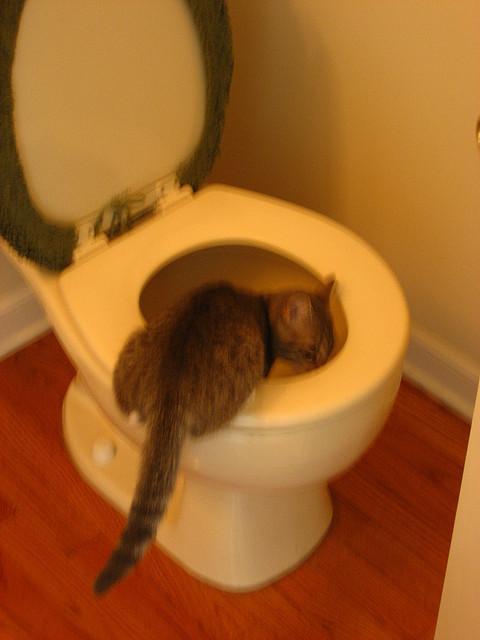How many toilets are there?
Give a very brief answer. 1. 